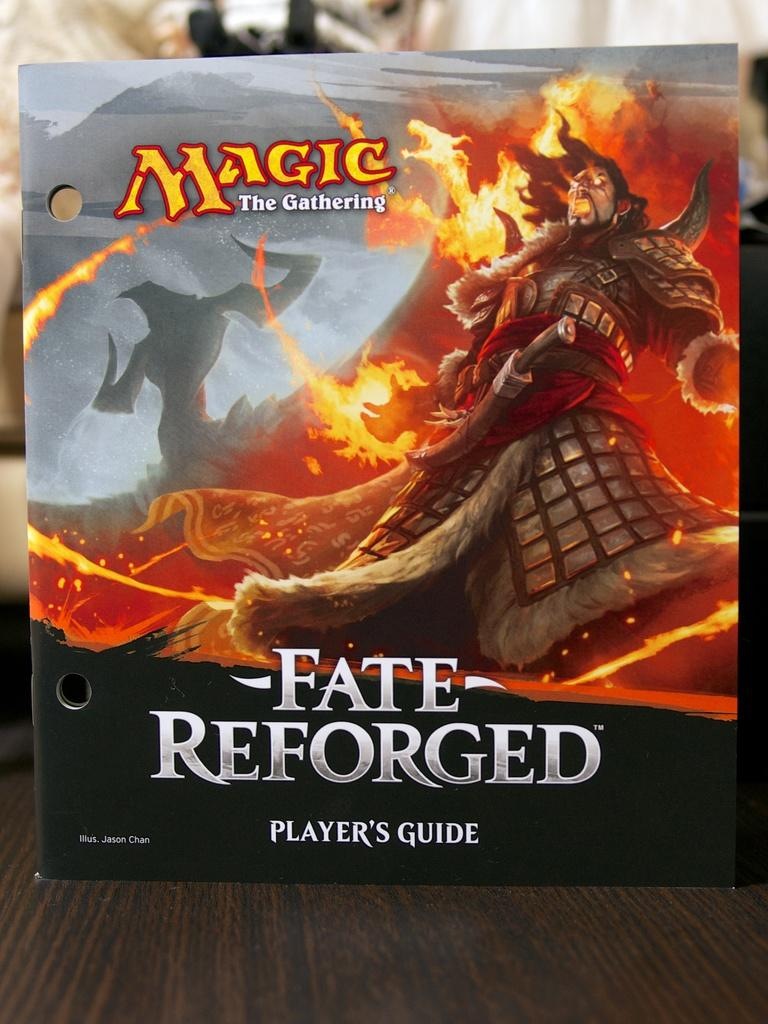<image>
Provide a brief description of the given image. A player's guide for the Fate Reforged game. 